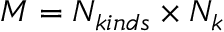<formula> <loc_0><loc_0><loc_500><loc_500>M = N _ { k i n d s } \times N _ { k }</formula> 